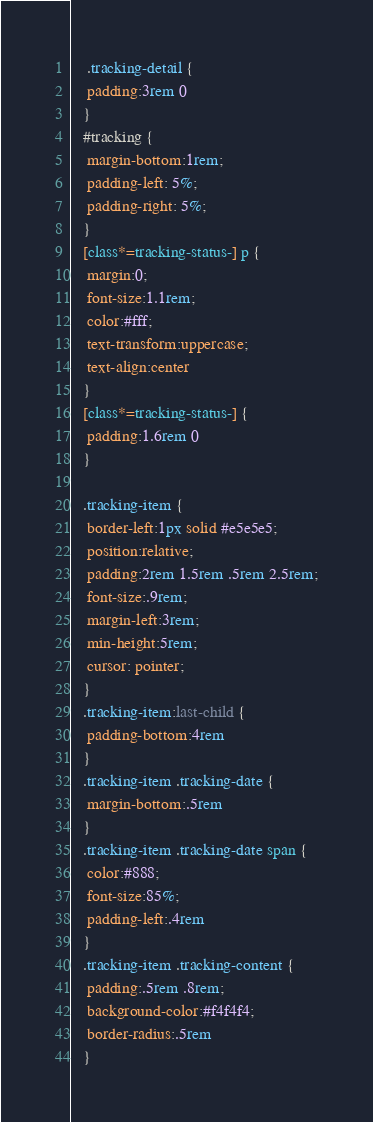Convert code to text. <code><loc_0><loc_0><loc_500><loc_500><_CSS_>
    .tracking-detail {
    padding:3rem 0
   }
   #tracking {
    margin-bottom:1rem;
    padding-left: 5%;
    padding-right: 5%;
   }
   [class*=tracking-status-] p {
    margin:0;
    font-size:1.1rem;
    color:#fff;
    text-transform:uppercase;
    text-align:center
   }
   [class*=tracking-status-] {
    padding:1.6rem 0
   }

   .tracking-item {
    border-left:1px solid #e5e5e5;
    position:relative;
    padding:2rem 1.5rem .5rem 2.5rem;
    font-size:.9rem;
    margin-left:3rem;
    min-height:5rem;
    cursor: pointer;
   }
   .tracking-item:last-child {
    padding-bottom:4rem
   }
   .tracking-item .tracking-date {
    margin-bottom:.5rem
   }
   .tracking-item .tracking-date span {
    color:#888;
    font-size:85%;
    padding-left:.4rem
   }
   .tracking-item .tracking-content {
    padding:.5rem .8rem;
    background-color:#f4f4f4;
    border-radius:.5rem
   }</code> 